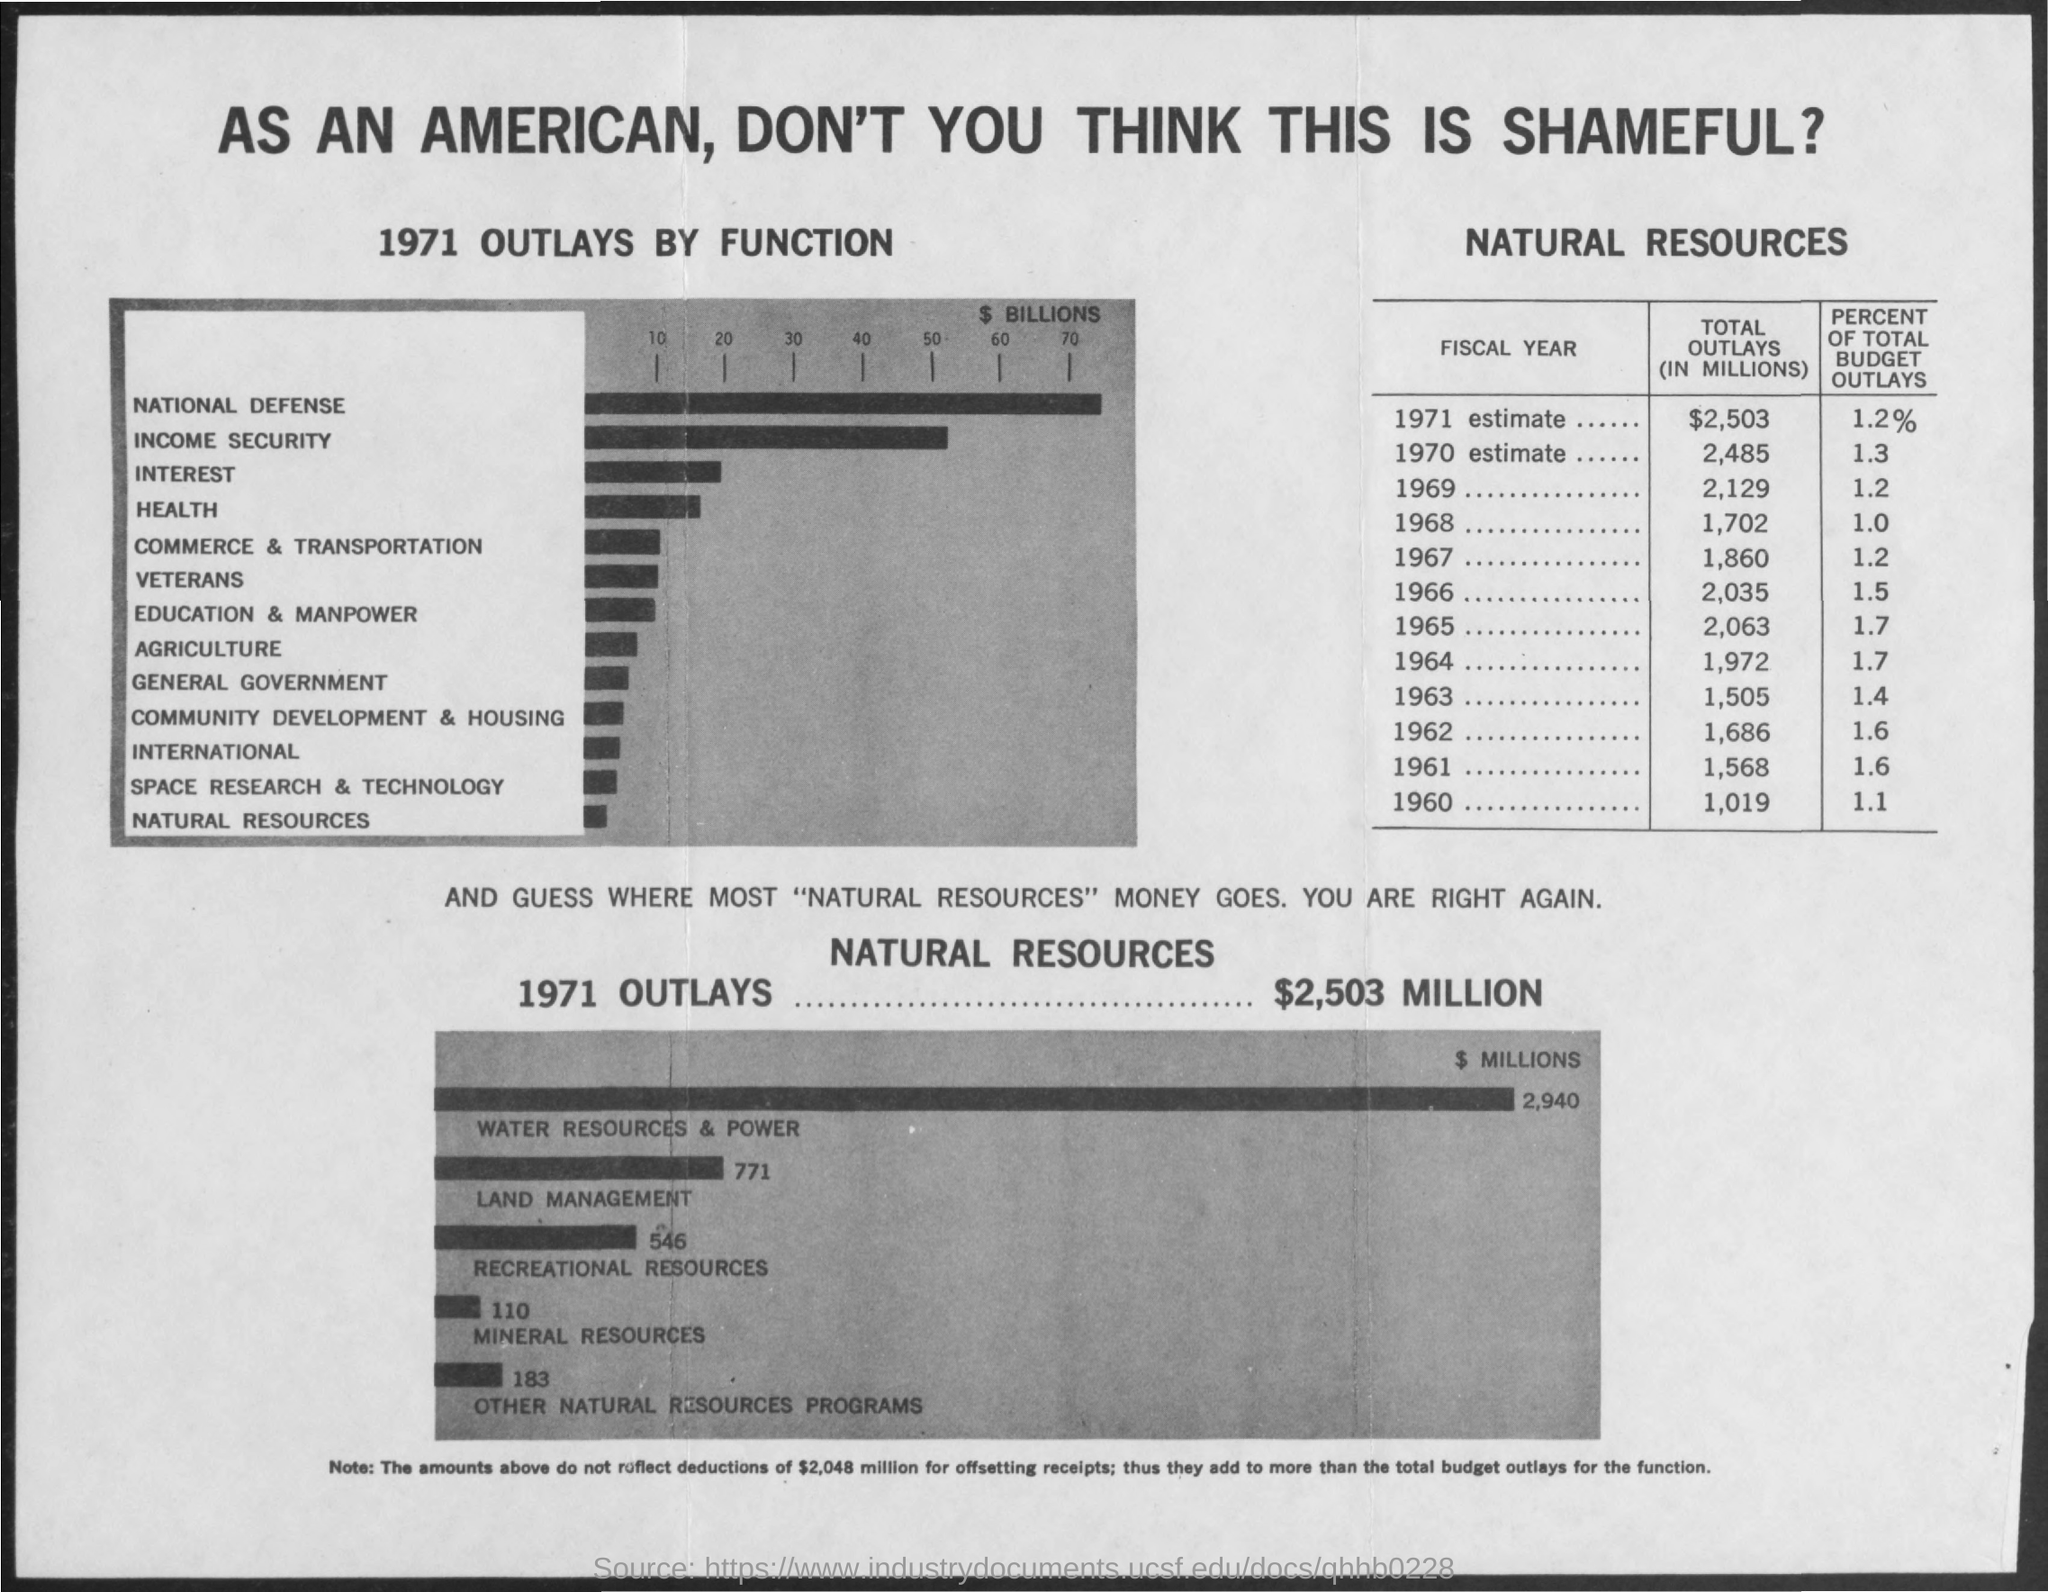What is the title of the document?
Keep it short and to the point. As an american, don't you think this is shameful?. What is the total outlay in 1969?
Provide a succinct answer. 2,129. What is the total outlay in 1960?
Your response must be concise. 1,019. Total outlay is maximum in which year?
Ensure brevity in your answer.  1971. Total outlay is minimum in which year?
Your response must be concise. 1960. What is the percentage of total budget outlays in 1971?
Ensure brevity in your answer.  1.2%. The percentage of total budget outlay is minimum in which year?
Your answer should be very brief. 1968. The outlay in 1971 is minimum for which function?
Offer a terse response. Natural Resources. The outlay in 1971 is maximum for which Natural Resource?
Your answer should be very brief. Water Resources & Power. 